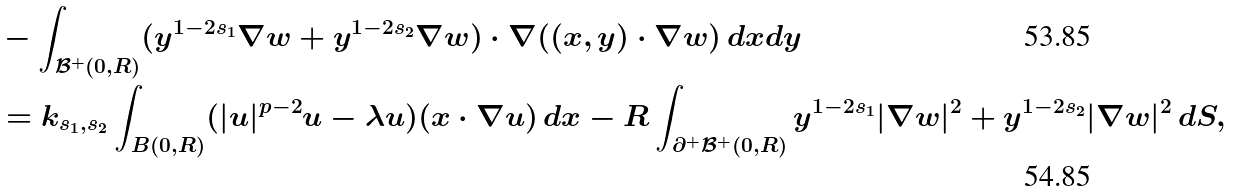Convert formula to latex. <formula><loc_0><loc_0><loc_500><loc_500>& - \int _ { \mathcal { B } ^ { + } ( 0 , R ) } ( y ^ { 1 - 2 s _ { 1 } } \nabla w + y ^ { 1 - 2 s _ { 2 } } \nabla w ) \cdot \nabla ( ( x , y ) \cdot \nabla w ) \, d x d y \\ & = k _ { s _ { 1 } , s _ { 2 } } \int _ { B ( 0 , R ) } ( | u | ^ { p - 2 } u - \lambda u ) ( x \cdot \nabla u ) \, d x - R \int _ { \partial ^ { + } \mathcal { B } ^ { + } ( 0 , R ) } y ^ { 1 - 2 s _ { 1 } } | \nabla w | ^ { 2 } + y ^ { 1 - 2 s _ { 2 } } | \nabla w | ^ { 2 } \, d S ,</formula> 